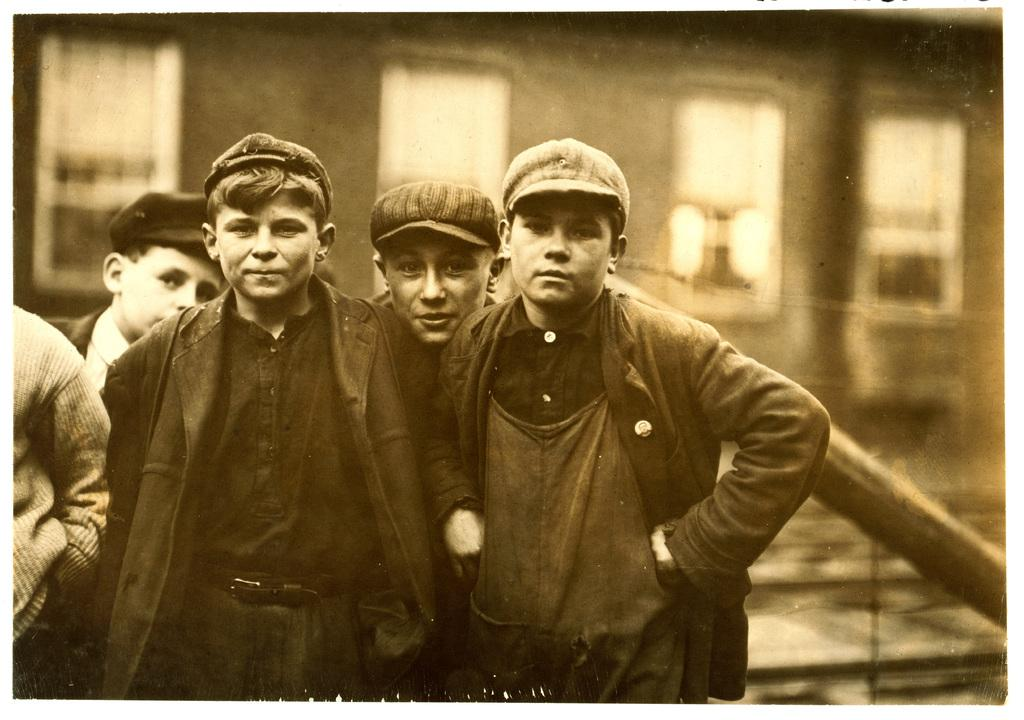What can be seen in the foreground of the image? There are people standing in the front of the image. What are the people wearing on their heads? The people are wearing caps. How would you describe the background of the image? The background of the image is blurry. What structures can be seen in the background? There is a building and a rod in the background. Can you tell me how many bones are visible in the image? There are no bones present in the image. What role does the actor play in the image? There is no actor present in the image, as the subjects are people wearing caps. --- 